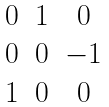<formula> <loc_0><loc_0><loc_500><loc_500>\begin{matrix} 0 & 1 & 0 \\ 0 & 0 & - 1 \\ 1 & 0 & 0 \end{matrix}</formula> 